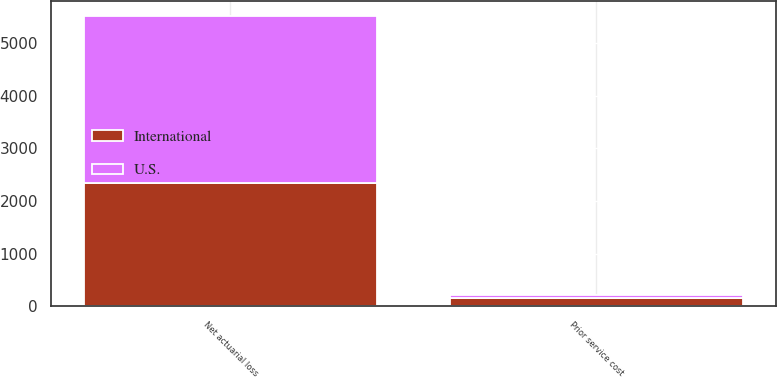Convert chart. <chart><loc_0><loc_0><loc_500><loc_500><stacked_bar_chart><ecel><fcel>Prior service cost<fcel>Net actuarial loss<nl><fcel>U.S.<fcel>62<fcel>3165<nl><fcel>International<fcel>157<fcel>2353<nl></chart> 